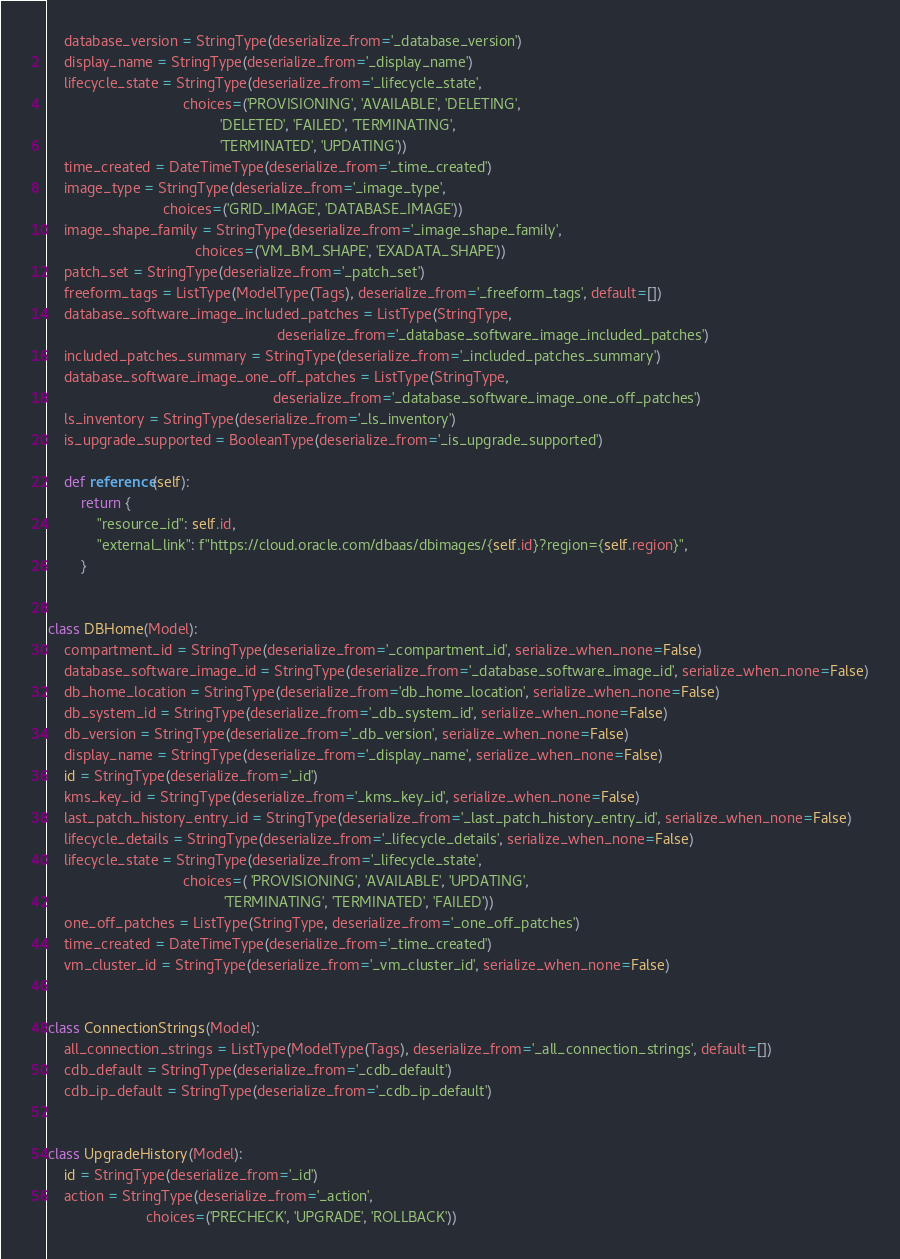Convert code to text. <code><loc_0><loc_0><loc_500><loc_500><_Python_>    database_version = StringType(deserialize_from='_database_version')
    display_name = StringType(deserialize_from='_display_name')
    lifecycle_state = StringType(deserialize_from='_lifecycle_state',
                                 choices=('PROVISIONING', 'AVAILABLE', 'DELETING',
                                          'DELETED', 'FAILED', 'TERMINATING',
                                          'TERMINATED', 'UPDATING'))
    time_created = DateTimeType(deserialize_from='_time_created')
    image_type = StringType(deserialize_from='_image_type',
                            choices=('GRID_IMAGE', 'DATABASE_IMAGE'))
    image_shape_family = StringType(deserialize_from='_image_shape_family',
                                    choices=('VM_BM_SHAPE', 'EXADATA_SHAPE'))
    patch_set = StringType(deserialize_from='_patch_set')
    freeform_tags = ListType(ModelType(Tags), deserialize_from='_freeform_tags', default=[])
    database_software_image_included_patches = ListType(StringType,
                                                        deserialize_from='_database_software_image_included_patches')
    included_patches_summary = StringType(deserialize_from='_included_patches_summary')
    database_software_image_one_off_patches = ListType(StringType,
                                                       deserialize_from='_database_software_image_one_off_patches')
    ls_inventory = StringType(deserialize_from='_ls_inventory')
    is_upgrade_supported = BooleanType(deserialize_from='_is_upgrade_supported')

    def reference(self):
        return {
            "resource_id": self.id,
            "external_link": f"https://cloud.oracle.com/dbaas/dbimages/{self.id}?region={self.region}",
        }


class DBHome(Model):
    compartment_id = StringType(deserialize_from='_compartment_id', serialize_when_none=False)
    database_software_image_id = StringType(deserialize_from='_database_software_image_id', serialize_when_none=False)
    db_home_location = StringType(deserialize_from='db_home_location', serialize_when_none=False)
    db_system_id = StringType(deserialize_from='_db_system_id', serialize_when_none=False)
    db_version = StringType(deserialize_from='_db_version', serialize_when_none=False)
    display_name = StringType(deserialize_from='_display_name', serialize_when_none=False)
    id = StringType(deserialize_from='_id')
    kms_key_id = StringType(deserialize_from='_kms_key_id', serialize_when_none=False)
    last_patch_history_entry_id = StringType(deserialize_from='_last_patch_history_entry_id', serialize_when_none=False)
    lifecycle_details = StringType(deserialize_from='_lifecycle_details', serialize_when_none=False)
    lifecycle_state = StringType(deserialize_from='_lifecycle_state',
                                 choices=( 'PROVISIONING', 'AVAILABLE', 'UPDATING',
                                           'TERMINATING', 'TERMINATED', 'FAILED'))
    one_off_patches = ListType(StringType, deserialize_from='_one_off_patches')
    time_created = DateTimeType(deserialize_from='_time_created')
    vm_cluster_id = StringType(deserialize_from='_vm_cluster_id', serialize_when_none=False)


class ConnectionStrings(Model):
    all_connection_strings = ListType(ModelType(Tags), deserialize_from='_all_connection_strings', default=[])
    cdb_default = StringType(deserialize_from='_cdb_default')
    cdb_ip_default = StringType(deserialize_from='_cdb_ip_default')


class UpgradeHistory(Model):
    id = StringType(deserialize_from='_id')
    action = StringType(deserialize_from='_action',
                        choices=('PRECHECK', 'UPGRADE', 'ROLLBACK'))</code> 